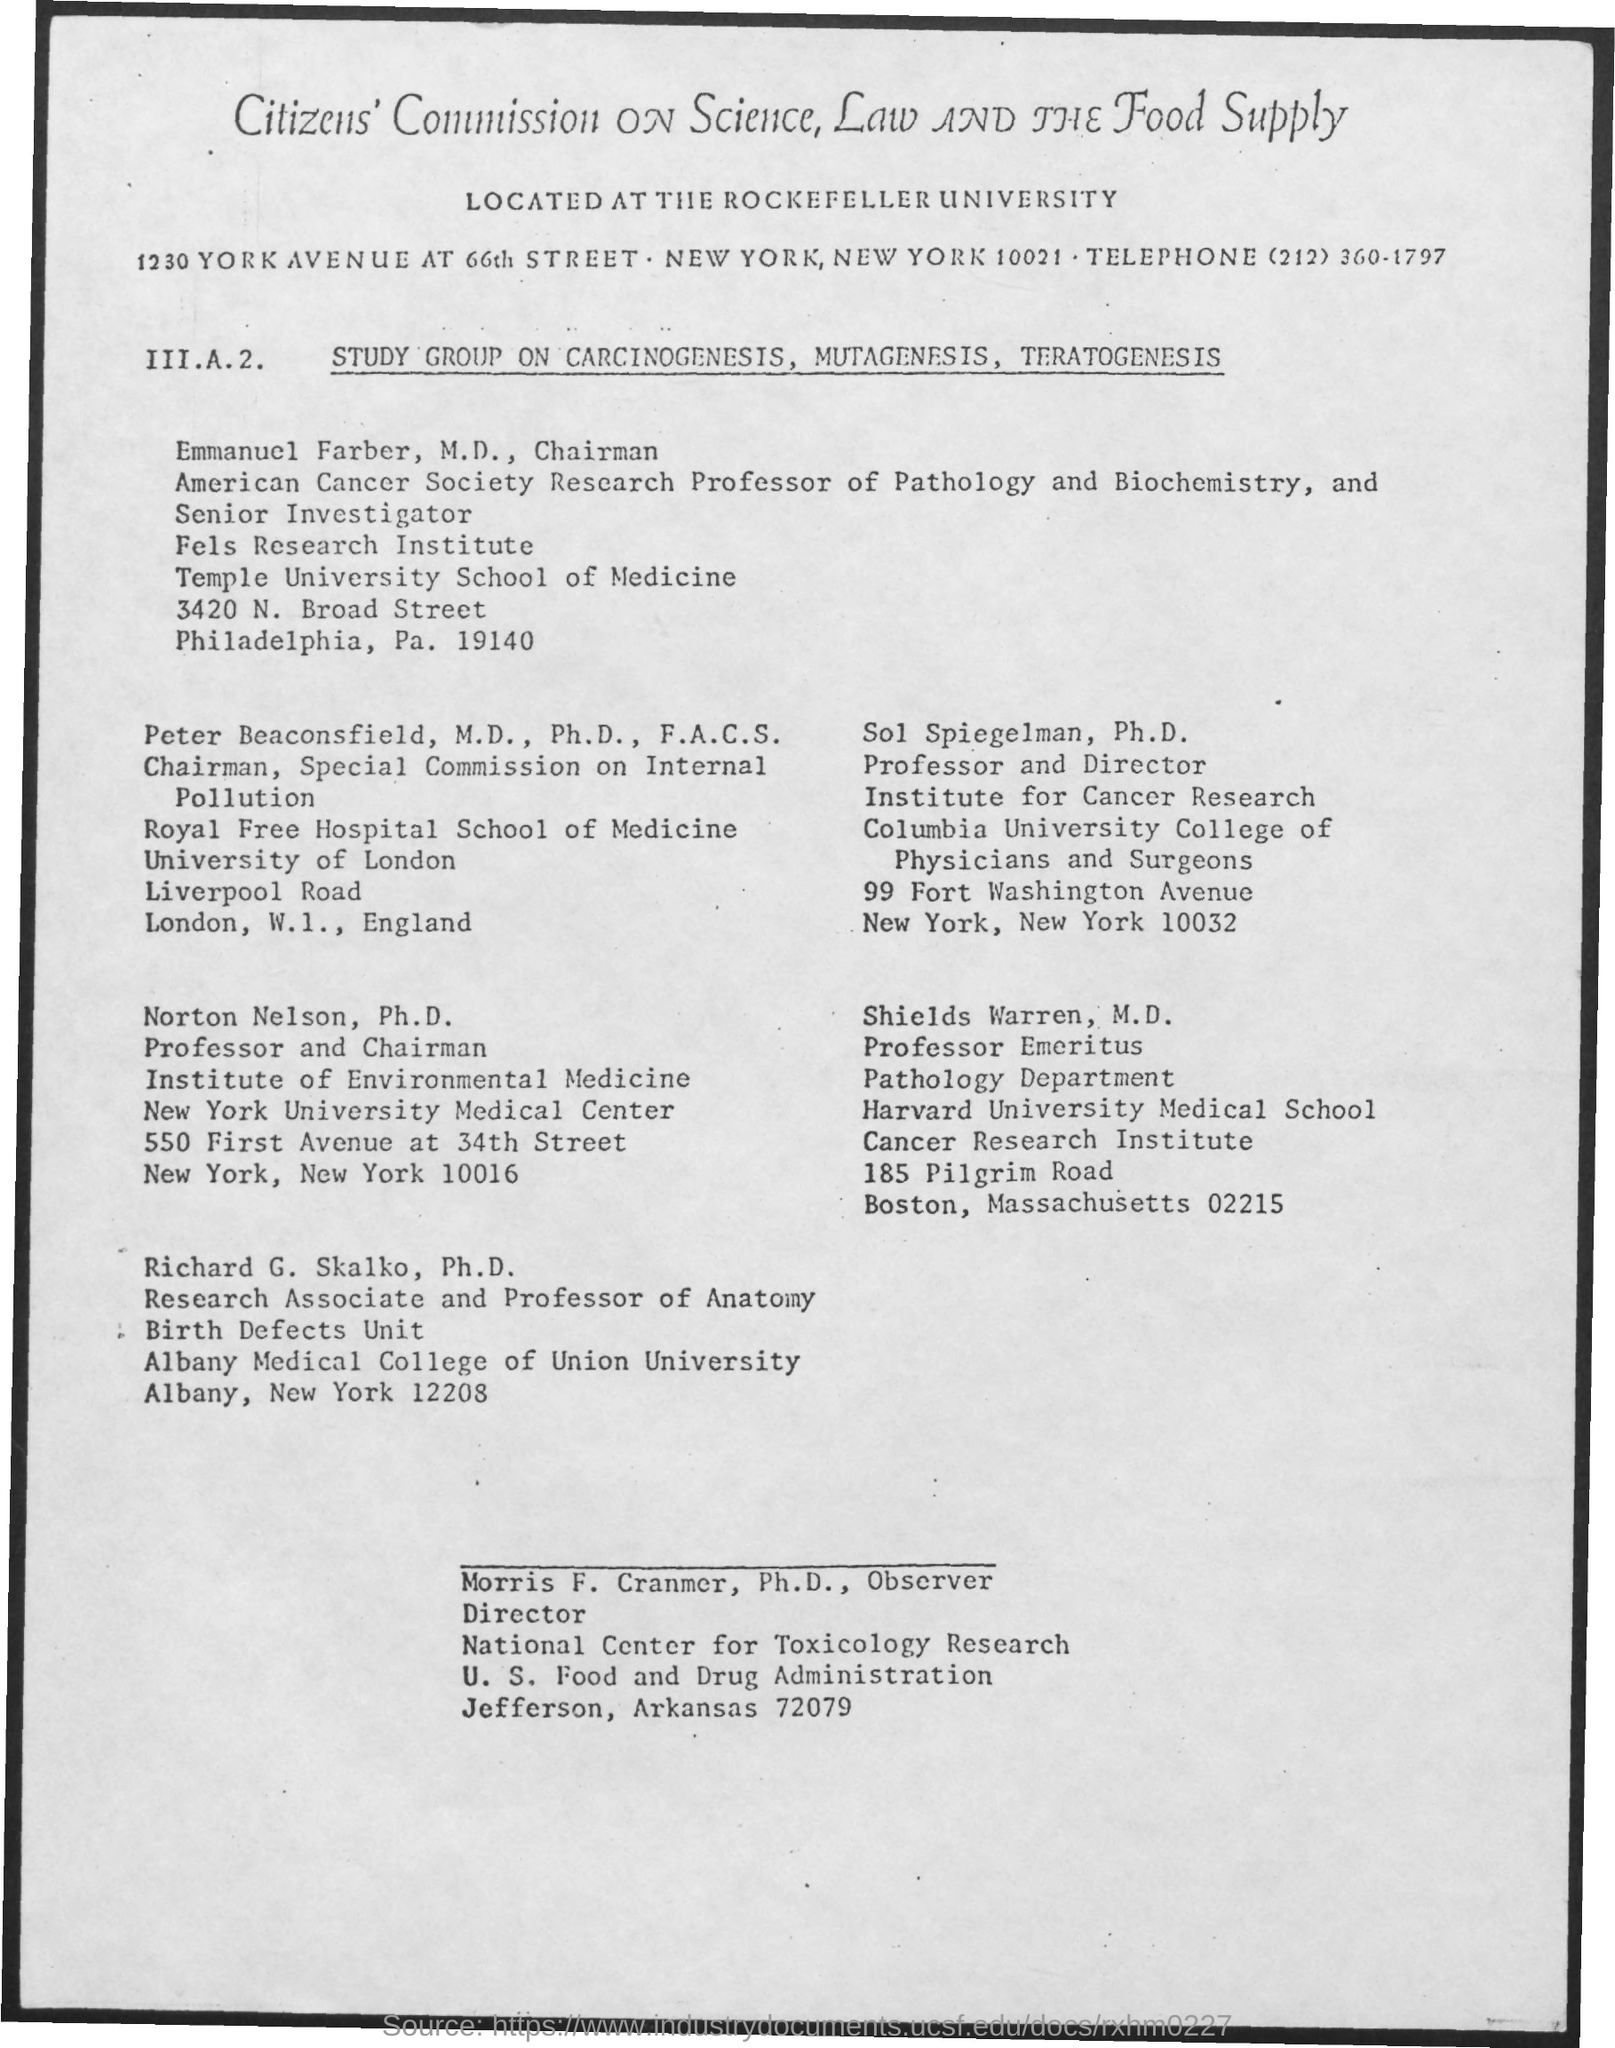Mention a couple of crucial points in this snapshot. The director of the National Center for Toxicology Research is Morris F. Cranmer, Ph.D., who serves as the Observer Director. The Special Commission on Internal Pollution is chaired by Peter Beaconsfield. 